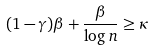<formula> <loc_0><loc_0><loc_500><loc_500>( 1 - \gamma ) \beta + \frac { \beta } { \log n } \geq \kappa</formula> 